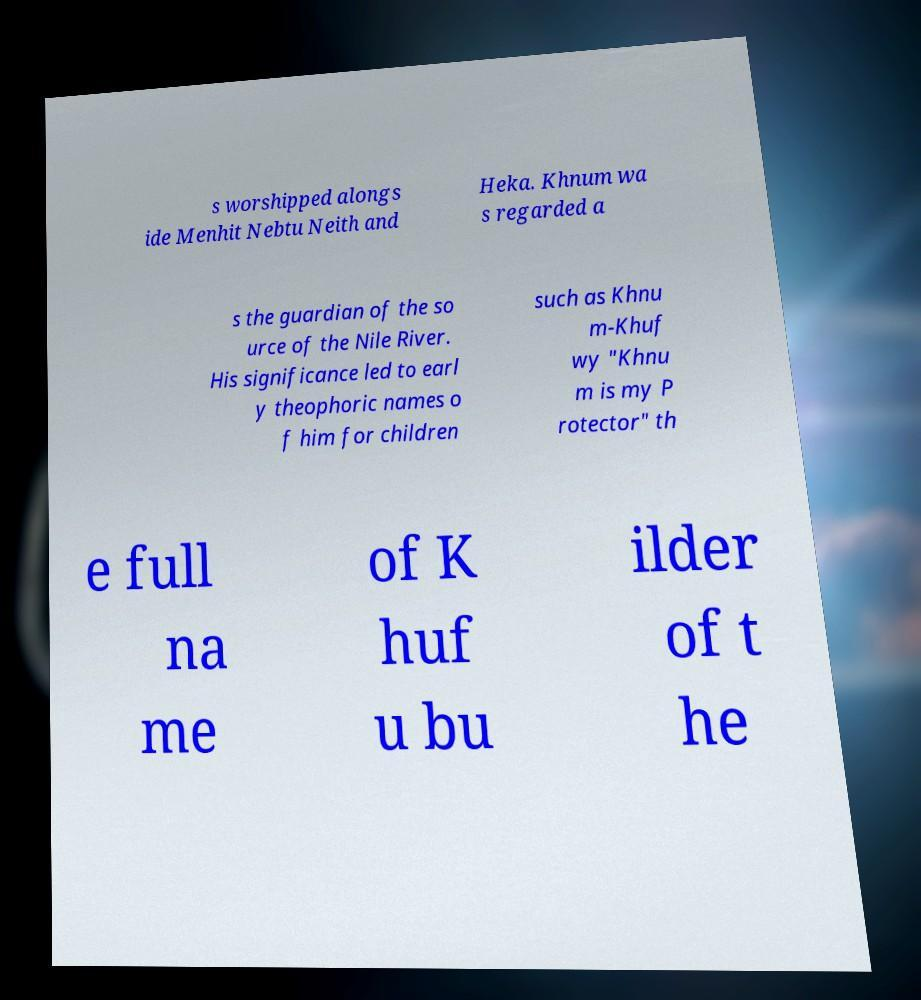Please identify and transcribe the text found in this image. s worshipped alongs ide Menhit Nebtu Neith and Heka. Khnum wa s regarded a s the guardian of the so urce of the Nile River. His significance led to earl y theophoric names o f him for children such as Khnu m-Khuf wy "Khnu m is my P rotector" th e full na me of K huf u bu ilder of t he 